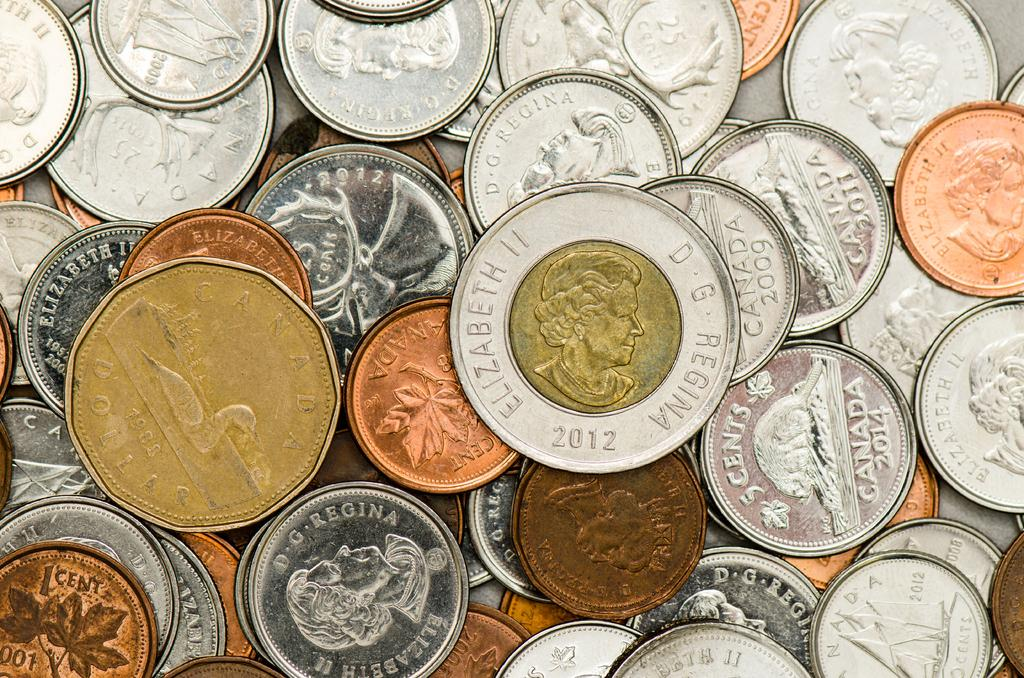<image>
Create a compact narrative representing the image presented. A coin with a gold center has the year 2012 on it. 